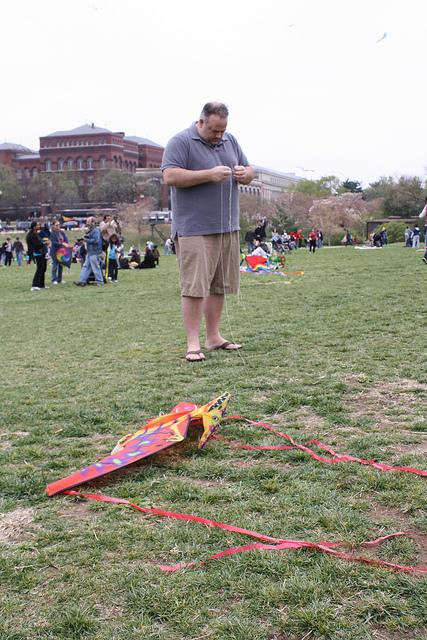What is the red object on the ground capable of?

Choices:
A) driving around
B) flight
C) playing music
D) catching fish flight 